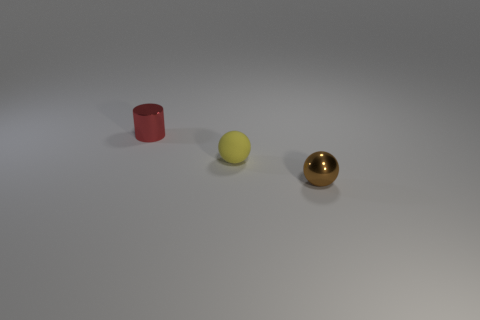Add 2 yellow matte spheres. How many objects exist? 5 Subtract 1 cylinders. How many cylinders are left? 0 Subtract all spheres. How many objects are left? 1 Add 2 rubber spheres. How many rubber spheres are left? 3 Add 3 tiny yellow metal blocks. How many tiny yellow metal blocks exist? 3 Subtract 0 blue blocks. How many objects are left? 3 Subtract all yellow cylinders. Subtract all red balls. How many cylinders are left? 1 Subtract all tiny matte objects. Subtract all shiny cylinders. How many objects are left? 1 